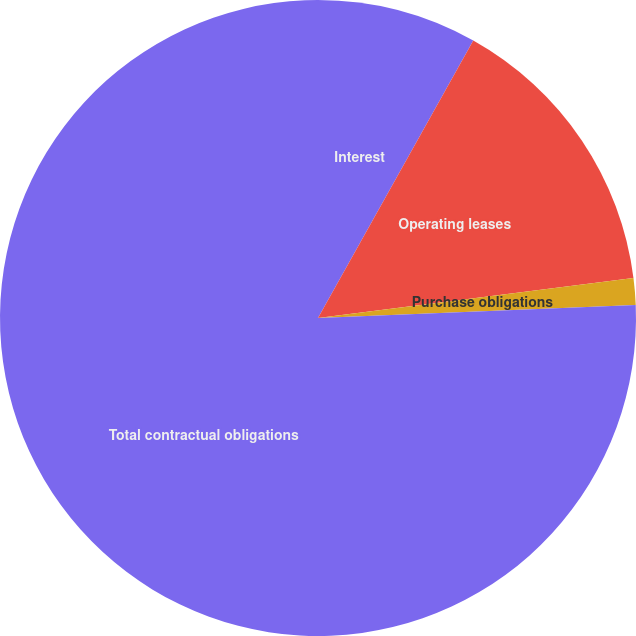<chart> <loc_0><loc_0><loc_500><loc_500><pie_chart><fcel>Interest<fcel>Operating leases<fcel>Purchase obligations<fcel>Total contractual obligations<nl><fcel>8.12%<fcel>14.87%<fcel>1.36%<fcel>75.65%<nl></chart> 